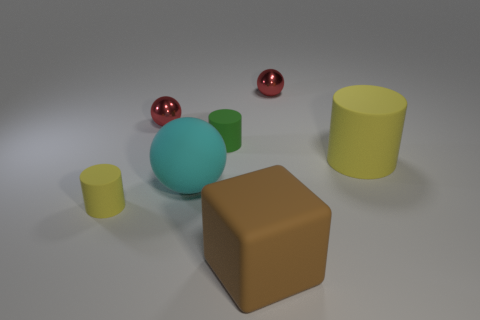There is a thing on the left side of the tiny red sphere that is on the left side of the tiny green object; is there a big cylinder that is to the left of it?
Your answer should be compact. No. Is the big ball made of the same material as the green thing?
Offer a terse response. Yes. Is there any other thing that is the same shape as the large brown thing?
Your answer should be very brief. No. There is a red thing behind the tiny metallic thing to the left of the cyan sphere; what is it made of?
Your answer should be very brief. Metal. There is a sphere that is to the right of the large cyan object; what is its size?
Your answer should be very brief. Small. The small thing that is behind the green matte thing and on the left side of the small green object is what color?
Provide a succinct answer. Red. There is a yellow cylinder left of the green cylinder; is it the same size as the small green rubber cylinder?
Your answer should be very brief. Yes. There is a small metallic thing that is to the right of the brown rubber thing; is there a yellow cylinder left of it?
Give a very brief answer. Yes. What is the small green cylinder made of?
Your answer should be very brief. Rubber. Are there any yellow matte cylinders on the left side of the big brown block?
Offer a terse response. Yes. 